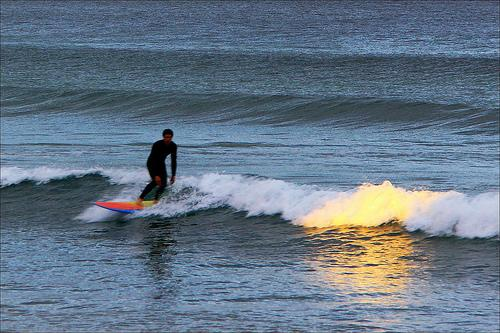How is the man's hair described in the image, and what are its dimensions? The man has dark, short black hair with dimensions of 14x14. Analyze the emotional tone or sentiment of the image. The image conveys feelings of excitement, adventure, and freedom. Identify the caption(s) describing the surfboard and provide a summarized description. The surfboard is described as red and blue with yellow on the top and has a size of approximately 70x70. Examine the image and provide a detailed description of the man's wetsuit. The man's wetsuit is black, full-body, and has a size of approximately 47x47. In the context of object detection, describe what is most noticeable about the water in the image. The water is mostly blue with small forming waves, some larger waves, and white foam near the man. Identify the primary object(s) interacting in the scene. A man wearing a wetsuit and surfboard amidst ocean waves. Provide a brief description of what is happening in the image. A man in a wetsuit is surfing on a red and blue surfboard amid white and blue ocean waves. What is the color of the trim on the board? Blue Can you find a woman wearing a pink wetsuit on a surfboard? The surfer in the image is a man wearing a black wetsuit, not a woman in a pink wetsuit. Do you see a large white boat in the background of the image? No, it's not mentioned in the image. Express the overall atmosphere of the sea water in the image. Large and calm What color is the surfboard's surface? Red What is the main activity happening in the image? A man is surfing on a wave. Describe the position of the surfer's arms. The surfer's arms are hanging over the sides of the surfboard. Describe the man while mentioning the wetsuit. A man wearing a black wetsuit with dark short hair is surfing on a wave. What type of image is this? An image of a man surfing on a wave in the ocean. Choose the correct description for the man's wetsuit: (A) black full suit (B) red and green half suit (C) blue and white striped suit. A) black full suit What is the short phrase that could describe the person in the image? Surfer Describe the scene with a focus on the surfer and the surfboard. A man with black hair wearing a black wetsuit is riding a red and blue surfboard with a yellow top on a wavy body of water. Is the surfboard the surfer is using green and purple? The surfboard in the image is red and blue, not green and purple. Describe what the man is doing in the context of his surfboard. The man is standing on the surfboard, wearing a black wetsuit, riding a wave. Describe the surfboard. Red and blue with a yellow top, blue trim, and a red surface. What is happening in the far background of the image? Small white and blue ocean waves are visible. What can you observe about the man's feet on the surfboard? Both of the man's feet are on the surfboard. What is creating yellow glare in the image? Sun shining on the wave Where is the sun shining on the wave? At a small section on the top-right side of the wave. What color is the surfer's hair? Black Identify the dominant colors of the ocean waves. White and blue What is the state of the water in the image? Wavy with white foam and small waves forming. 